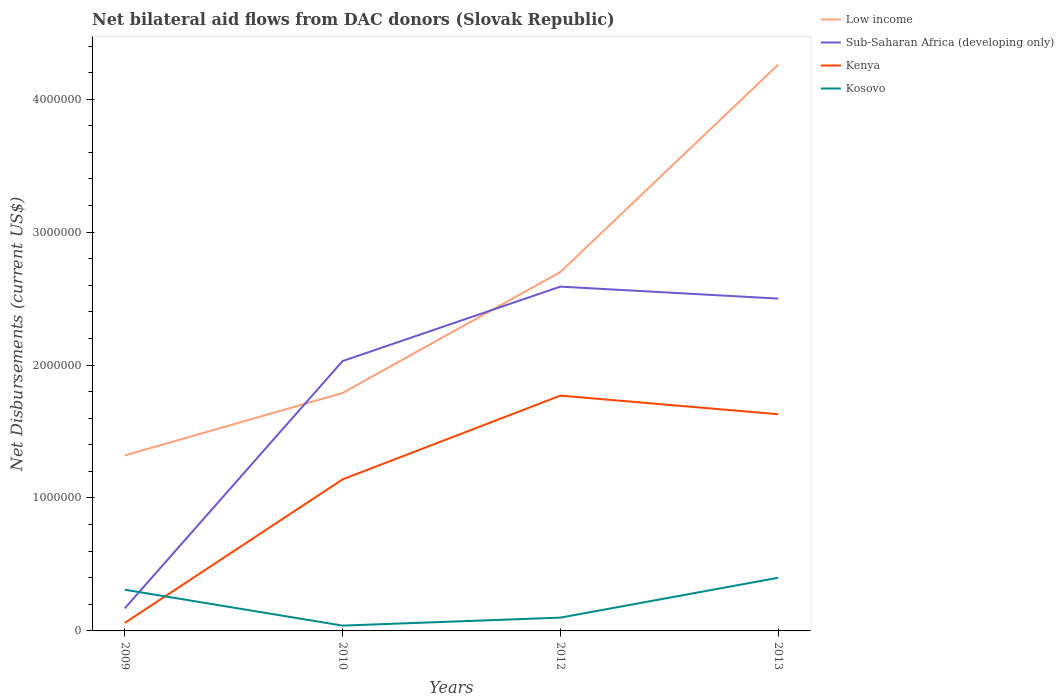Does the line corresponding to Sub-Saharan Africa (developing only) intersect with the line corresponding to Kosovo?
Your answer should be compact. Yes. What is the total net bilateral aid flows in Kosovo in the graph?
Your answer should be compact. -3.00e+05. What is the difference between the highest and the second highest net bilateral aid flows in Kenya?
Provide a succinct answer. 1.71e+06. What is the difference between the highest and the lowest net bilateral aid flows in Sub-Saharan Africa (developing only)?
Your response must be concise. 3. Is the net bilateral aid flows in Sub-Saharan Africa (developing only) strictly greater than the net bilateral aid flows in Low income over the years?
Keep it short and to the point. No. How many years are there in the graph?
Your answer should be compact. 4. Are the values on the major ticks of Y-axis written in scientific E-notation?
Ensure brevity in your answer.  No. Does the graph contain grids?
Your answer should be compact. No. How many legend labels are there?
Make the answer very short. 4. What is the title of the graph?
Your response must be concise. Net bilateral aid flows from DAC donors (Slovak Republic). Does "Angola" appear as one of the legend labels in the graph?
Your response must be concise. No. What is the label or title of the X-axis?
Give a very brief answer. Years. What is the label or title of the Y-axis?
Provide a succinct answer. Net Disbursements (current US$). What is the Net Disbursements (current US$) of Low income in 2009?
Keep it short and to the point. 1.32e+06. What is the Net Disbursements (current US$) in Sub-Saharan Africa (developing only) in 2009?
Offer a terse response. 1.70e+05. What is the Net Disbursements (current US$) of Kenya in 2009?
Offer a terse response. 6.00e+04. What is the Net Disbursements (current US$) of Kosovo in 2009?
Give a very brief answer. 3.10e+05. What is the Net Disbursements (current US$) in Low income in 2010?
Offer a terse response. 1.79e+06. What is the Net Disbursements (current US$) of Sub-Saharan Africa (developing only) in 2010?
Offer a terse response. 2.03e+06. What is the Net Disbursements (current US$) in Kenya in 2010?
Your answer should be very brief. 1.14e+06. What is the Net Disbursements (current US$) of Low income in 2012?
Offer a terse response. 2.70e+06. What is the Net Disbursements (current US$) of Sub-Saharan Africa (developing only) in 2012?
Give a very brief answer. 2.59e+06. What is the Net Disbursements (current US$) of Kenya in 2012?
Give a very brief answer. 1.77e+06. What is the Net Disbursements (current US$) of Low income in 2013?
Keep it short and to the point. 4.26e+06. What is the Net Disbursements (current US$) in Sub-Saharan Africa (developing only) in 2013?
Give a very brief answer. 2.50e+06. What is the Net Disbursements (current US$) in Kenya in 2013?
Give a very brief answer. 1.63e+06. Across all years, what is the maximum Net Disbursements (current US$) in Low income?
Provide a succinct answer. 4.26e+06. Across all years, what is the maximum Net Disbursements (current US$) in Sub-Saharan Africa (developing only)?
Your response must be concise. 2.59e+06. Across all years, what is the maximum Net Disbursements (current US$) in Kenya?
Ensure brevity in your answer.  1.77e+06. Across all years, what is the maximum Net Disbursements (current US$) of Kosovo?
Your answer should be compact. 4.00e+05. Across all years, what is the minimum Net Disbursements (current US$) of Low income?
Offer a terse response. 1.32e+06. Across all years, what is the minimum Net Disbursements (current US$) in Sub-Saharan Africa (developing only)?
Provide a succinct answer. 1.70e+05. Across all years, what is the minimum Net Disbursements (current US$) of Kenya?
Your answer should be very brief. 6.00e+04. Across all years, what is the minimum Net Disbursements (current US$) of Kosovo?
Give a very brief answer. 4.00e+04. What is the total Net Disbursements (current US$) of Low income in the graph?
Your answer should be very brief. 1.01e+07. What is the total Net Disbursements (current US$) in Sub-Saharan Africa (developing only) in the graph?
Ensure brevity in your answer.  7.29e+06. What is the total Net Disbursements (current US$) of Kenya in the graph?
Make the answer very short. 4.60e+06. What is the total Net Disbursements (current US$) in Kosovo in the graph?
Provide a succinct answer. 8.50e+05. What is the difference between the Net Disbursements (current US$) of Low income in 2009 and that in 2010?
Ensure brevity in your answer.  -4.70e+05. What is the difference between the Net Disbursements (current US$) in Sub-Saharan Africa (developing only) in 2009 and that in 2010?
Your response must be concise. -1.86e+06. What is the difference between the Net Disbursements (current US$) of Kenya in 2009 and that in 2010?
Ensure brevity in your answer.  -1.08e+06. What is the difference between the Net Disbursements (current US$) of Kosovo in 2009 and that in 2010?
Make the answer very short. 2.70e+05. What is the difference between the Net Disbursements (current US$) in Low income in 2009 and that in 2012?
Keep it short and to the point. -1.38e+06. What is the difference between the Net Disbursements (current US$) of Sub-Saharan Africa (developing only) in 2009 and that in 2012?
Make the answer very short. -2.42e+06. What is the difference between the Net Disbursements (current US$) in Kenya in 2009 and that in 2012?
Offer a terse response. -1.71e+06. What is the difference between the Net Disbursements (current US$) of Kosovo in 2009 and that in 2012?
Offer a terse response. 2.10e+05. What is the difference between the Net Disbursements (current US$) of Low income in 2009 and that in 2013?
Ensure brevity in your answer.  -2.94e+06. What is the difference between the Net Disbursements (current US$) of Sub-Saharan Africa (developing only) in 2009 and that in 2013?
Your answer should be very brief. -2.33e+06. What is the difference between the Net Disbursements (current US$) of Kenya in 2009 and that in 2013?
Offer a very short reply. -1.57e+06. What is the difference between the Net Disbursements (current US$) of Kosovo in 2009 and that in 2013?
Your answer should be very brief. -9.00e+04. What is the difference between the Net Disbursements (current US$) of Low income in 2010 and that in 2012?
Provide a succinct answer. -9.10e+05. What is the difference between the Net Disbursements (current US$) of Sub-Saharan Africa (developing only) in 2010 and that in 2012?
Offer a very short reply. -5.60e+05. What is the difference between the Net Disbursements (current US$) of Kenya in 2010 and that in 2012?
Your answer should be very brief. -6.30e+05. What is the difference between the Net Disbursements (current US$) of Low income in 2010 and that in 2013?
Make the answer very short. -2.47e+06. What is the difference between the Net Disbursements (current US$) of Sub-Saharan Africa (developing only) in 2010 and that in 2013?
Your answer should be compact. -4.70e+05. What is the difference between the Net Disbursements (current US$) of Kenya in 2010 and that in 2013?
Your answer should be compact. -4.90e+05. What is the difference between the Net Disbursements (current US$) in Kosovo in 2010 and that in 2013?
Offer a terse response. -3.60e+05. What is the difference between the Net Disbursements (current US$) of Low income in 2012 and that in 2013?
Your response must be concise. -1.56e+06. What is the difference between the Net Disbursements (current US$) in Kosovo in 2012 and that in 2013?
Ensure brevity in your answer.  -3.00e+05. What is the difference between the Net Disbursements (current US$) in Low income in 2009 and the Net Disbursements (current US$) in Sub-Saharan Africa (developing only) in 2010?
Make the answer very short. -7.10e+05. What is the difference between the Net Disbursements (current US$) of Low income in 2009 and the Net Disbursements (current US$) of Kenya in 2010?
Keep it short and to the point. 1.80e+05. What is the difference between the Net Disbursements (current US$) in Low income in 2009 and the Net Disbursements (current US$) in Kosovo in 2010?
Make the answer very short. 1.28e+06. What is the difference between the Net Disbursements (current US$) of Sub-Saharan Africa (developing only) in 2009 and the Net Disbursements (current US$) of Kenya in 2010?
Provide a succinct answer. -9.70e+05. What is the difference between the Net Disbursements (current US$) in Kenya in 2009 and the Net Disbursements (current US$) in Kosovo in 2010?
Your answer should be compact. 2.00e+04. What is the difference between the Net Disbursements (current US$) of Low income in 2009 and the Net Disbursements (current US$) of Sub-Saharan Africa (developing only) in 2012?
Offer a very short reply. -1.27e+06. What is the difference between the Net Disbursements (current US$) of Low income in 2009 and the Net Disbursements (current US$) of Kenya in 2012?
Ensure brevity in your answer.  -4.50e+05. What is the difference between the Net Disbursements (current US$) in Low income in 2009 and the Net Disbursements (current US$) in Kosovo in 2012?
Your answer should be very brief. 1.22e+06. What is the difference between the Net Disbursements (current US$) of Sub-Saharan Africa (developing only) in 2009 and the Net Disbursements (current US$) of Kenya in 2012?
Ensure brevity in your answer.  -1.60e+06. What is the difference between the Net Disbursements (current US$) of Sub-Saharan Africa (developing only) in 2009 and the Net Disbursements (current US$) of Kosovo in 2012?
Your response must be concise. 7.00e+04. What is the difference between the Net Disbursements (current US$) in Low income in 2009 and the Net Disbursements (current US$) in Sub-Saharan Africa (developing only) in 2013?
Offer a very short reply. -1.18e+06. What is the difference between the Net Disbursements (current US$) of Low income in 2009 and the Net Disbursements (current US$) of Kenya in 2013?
Ensure brevity in your answer.  -3.10e+05. What is the difference between the Net Disbursements (current US$) in Low income in 2009 and the Net Disbursements (current US$) in Kosovo in 2013?
Offer a very short reply. 9.20e+05. What is the difference between the Net Disbursements (current US$) of Sub-Saharan Africa (developing only) in 2009 and the Net Disbursements (current US$) of Kenya in 2013?
Offer a very short reply. -1.46e+06. What is the difference between the Net Disbursements (current US$) in Sub-Saharan Africa (developing only) in 2009 and the Net Disbursements (current US$) in Kosovo in 2013?
Provide a succinct answer. -2.30e+05. What is the difference between the Net Disbursements (current US$) of Low income in 2010 and the Net Disbursements (current US$) of Sub-Saharan Africa (developing only) in 2012?
Make the answer very short. -8.00e+05. What is the difference between the Net Disbursements (current US$) of Low income in 2010 and the Net Disbursements (current US$) of Kenya in 2012?
Your answer should be very brief. 2.00e+04. What is the difference between the Net Disbursements (current US$) in Low income in 2010 and the Net Disbursements (current US$) in Kosovo in 2012?
Offer a terse response. 1.69e+06. What is the difference between the Net Disbursements (current US$) of Sub-Saharan Africa (developing only) in 2010 and the Net Disbursements (current US$) of Kenya in 2012?
Ensure brevity in your answer.  2.60e+05. What is the difference between the Net Disbursements (current US$) in Sub-Saharan Africa (developing only) in 2010 and the Net Disbursements (current US$) in Kosovo in 2012?
Make the answer very short. 1.93e+06. What is the difference between the Net Disbursements (current US$) in Kenya in 2010 and the Net Disbursements (current US$) in Kosovo in 2012?
Provide a short and direct response. 1.04e+06. What is the difference between the Net Disbursements (current US$) in Low income in 2010 and the Net Disbursements (current US$) in Sub-Saharan Africa (developing only) in 2013?
Your answer should be very brief. -7.10e+05. What is the difference between the Net Disbursements (current US$) in Low income in 2010 and the Net Disbursements (current US$) in Kosovo in 2013?
Provide a succinct answer. 1.39e+06. What is the difference between the Net Disbursements (current US$) of Sub-Saharan Africa (developing only) in 2010 and the Net Disbursements (current US$) of Kosovo in 2013?
Your answer should be compact. 1.63e+06. What is the difference between the Net Disbursements (current US$) of Kenya in 2010 and the Net Disbursements (current US$) of Kosovo in 2013?
Offer a very short reply. 7.40e+05. What is the difference between the Net Disbursements (current US$) of Low income in 2012 and the Net Disbursements (current US$) of Kenya in 2013?
Your response must be concise. 1.07e+06. What is the difference between the Net Disbursements (current US$) in Low income in 2012 and the Net Disbursements (current US$) in Kosovo in 2013?
Offer a very short reply. 2.30e+06. What is the difference between the Net Disbursements (current US$) in Sub-Saharan Africa (developing only) in 2012 and the Net Disbursements (current US$) in Kenya in 2013?
Make the answer very short. 9.60e+05. What is the difference between the Net Disbursements (current US$) in Sub-Saharan Africa (developing only) in 2012 and the Net Disbursements (current US$) in Kosovo in 2013?
Your answer should be very brief. 2.19e+06. What is the difference between the Net Disbursements (current US$) in Kenya in 2012 and the Net Disbursements (current US$) in Kosovo in 2013?
Your response must be concise. 1.37e+06. What is the average Net Disbursements (current US$) of Low income per year?
Your response must be concise. 2.52e+06. What is the average Net Disbursements (current US$) of Sub-Saharan Africa (developing only) per year?
Your answer should be compact. 1.82e+06. What is the average Net Disbursements (current US$) of Kenya per year?
Offer a terse response. 1.15e+06. What is the average Net Disbursements (current US$) of Kosovo per year?
Offer a terse response. 2.12e+05. In the year 2009, what is the difference between the Net Disbursements (current US$) in Low income and Net Disbursements (current US$) in Sub-Saharan Africa (developing only)?
Make the answer very short. 1.15e+06. In the year 2009, what is the difference between the Net Disbursements (current US$) in Low income and Net Disbursements (current US$) in Kenya?
Keep it short and to the point. 1.26e+06. In the year 2009, what is the difference between the Net Disbursements (current US$) in Low income and Net Disbursements (current US$) in Kosovo?
Make the answer very short. 1.01e+06. In the year 2009, what is the difference between the Net Disbursements (current US$) in Kenya and Net Disbursements (current US$) in Kosovo?
Your response must be concise. -2.50e+05. In the year 2010, what is the difference between the Net Disbursements (current US$) in Low income and Net Disbursements (current US$) in Sub-Saharan Africa (developing only)?
Give a very brief answer. -2.40e+05. In the year 2010, what is the difference between the Net Disbursements (current US$) in Low income and Net Disbursements (current US$) in Kenya?
Offer a terse response. 6.50e+05. In the year 2010, what is the difference between the Net Disbursements (current US$) in Low income and Net Disbursements (current US$) in Kosovo?
Offer a terse response. 1.75e+06. In the year 2010, what is the difference between the Net Disbursements (current US$) of Sub-Saharan Africa (developing only) and Net Disbursements (current US$) of Kenya?
Provide a succinct answer. 8.90e+05. In the year 2010, what is the difference between the Net Disbursements (current US$) of Sub-Saharan Africa (developing only) and Net Disbursements (current US$) of Kosovo?
Provide a succinct answer. 1.99e+06. In the year 2010, what is the difference between the Net Disbursements (current US$) of Kenya and Net Disbursements (current US$) of Kosovo?
Give a very brief answer. 1.10e+06. In the year 2012, what is the difference between the Net Disbursements (current US$) of Low income and Net Disbursements (current US$) of Sub-Saharan Africa (developing only)?
Offer a very short reply. 1.10e+05. In the year 2012, what is the difference between the Net Disbursements (current US$) of Low income and Net Disbursements (current US$) of Kenya?
Keep it short and to the point. 9.30e+05. In the year 2012, what is the difference between the Net Disbursements (current US$) in Low income and Net Disbursements (current US$) in Kosovo?
Offer a very short reply. 2.60e+06. In the year 2012, what is the difference between the Net Disbursements (current US$) in Sub-Saharan Africa (developing only) and Net Disbursements (current US$) in Kenya?
Your answer should be compact. 8.20e+05. In the year 2012, what is the difference between the Net Disbursements (current US$) in Sub-Saharan Africa (developing only) and Net Disbursements (current US$) in Kosovo?
Provide a short and direct response. 2.49e+06. In the year 2012, what is the difference between the Net Disbursements (current US$) of Kenya and Net Disbursements (current US$) of Kosovo?
Offer a very short reply. 1.67e+06. In the year 2013, what is the difference between the Net Disbursements (current US$) in Low income and Net Disbursements (current US$) in Sub-Saharan Africa (developing only)?
Your answer should be very brief. 1.76e+06. In the year 2013, what is the difference between the Net Disbursements (current US$) of Low income and Net Disbursements (current US$) of Kenya?
Your answer should be very brief. 2.63e+06. In the year 2013, what is the difference between the Net Disbursements (current US$) in Low income and Net Disbursements (current US$) in Kosovo?
Your answer should be very brief. 3.86e+06. In the year 2013, what is the difference between the Net Disbursements (current US$) in Sub-Saharan Africa (developing only) and Net Disbursements (current US$) in Kenya?
Give a very brief answer. 8.70e+05. In the year 2013, what is the difference between the Net Disbursements (current US$) in Sub-Saharan Africa (developing only) and Net Disbursements (current US$) in Kosovo?
Provide a short and direct response. 2.10e+06. In the year 2013, what is the difference between the Net Disbursements (current US$) in Kenya and Net Disbursements (current US$) in Kosovo?
Offer a terse response. 1.23e+06. What is the ratio of the Net Disbursements (current US$) of Low income in 2009 to that in 2010?
Ensure brevity in your answer.  0.74. What is the ratio of the Net Disbursements (current US$) in Sub-Saharan Africa (developing only) in 2009 to that in 2010?
Your response must be concise. 0.08. What is the ratio of the Net Disbursements (current US$) in Kenya in 2009 to that in 2010?
Offer a terse response. 0.05. What is the ratio of the Net Disbursements (current US$) of Kosovo in 2009 to that in 2010?
Your answer should be very brief. 7.75. What is the ratio of the Net Disbursements (current US$) in Low income in 2009 to that in 2012?
Ensure brevity in your answer.  0.49. What is the ratio of the Net Disbursements (current US$) in Sub-Saharan Africa (developing only) in 2009 to that in 2012?
Make the answer very short. 0.07. What is the ratio of the Net Disbursements (current US$) of Kenya in 2009 to that in 2012?
Your answer should be very brief. 0.03. What is the ratio of the Net Disbursements (current US$) of Low income in 2009 to that in 2013?
Ensure brevity in your answer.  0.31. What is the ratio of the Net Disbursements (current US$) in Sub-Saharan Africa (developing only) in 2009 to that in 2013?
Offer a terse response. 0.07. What is the ratio of the Net Disbursements (current US$) of Kenya in 2009 to that in 2013?
Your response must be concise. 0.04. What is the ratio of the Net Disbursements (current US$) of Kosovo in 2009 to that in 2013?
Give a very brief answer. 0.78. What is the ratio of the Net Disbursements (current US$) in Low income in 2010 to that in 2012?
Make the answer very short. 0.66. What is the ratio of the Net Disbursements (current US$) in Sub-Saharan Africa (developing only) in 2010 to that in 2012?
Your response must be concise. 0.78. What is the ratio of the Net Disbursements (current US$) in Kenya in 2010 to that in 2012?
Provide a short and direct response. 0.64. What is the ratio of the Net Disbursements (current US$) in Low income in 2010 to that in 2013?
Your answer should be compact. 0.42. What is the ratio of the Net Disbursements (current US$) in Sub-Saharan Africa (developing only) in 2010 to that in 2013?
Make the answer very short. 0.81. What is the ratio of the Net Disbursements (current US$) in Kenya in 2010 to that in 2013?
Keep it short and to the point. 0.7. What is the ratio of the Net Disbursements (current US$) in Low income in 2012 to that in 2013?
Provide a short and direct response. 0.63. What is the ratio of the Net Disbursements (current US$) in Sub-Saharan Africa (developing only) in 2012 to that in 2013?
Make the answer very short. 1.04. What is the ratio of the Net Disbursements (current US$) in Kenya in 2012 to that in 2013?
Provide a succinct answer. 1.09. What is the ratio of the Net Disbursements (current US$) of Kosovo in 2012 to that in 2013?
Your answer should be very brief. 0.25. What is the difference between the highest and the second highest Net Disbursements (current US$) of Low income?
Offer a terse response. 1.56e+06. What is the difference between the highest and the second highest Net Disbursements (current US$) in Sub-Saharan Africa (developing only)?
Your answer should be compact. 9.00e+04. What is the difference between the highest and the second highest Net Disbursements (current US$) of Kosovo?
Keep it short and to the point. 9.00e+04. What is the difference between the highest and the lowest Net Disbursements (current US$) of Low income?
Your response must be concise. 2.94e+06. What is the difference between the highest and the lowest Net Disbursements (current US$) of Sub-Saharan Africa (developing only)?
Make the answer very short. 2.42e+06. What is the difference between the highest and the lowest Net Disbursements (current US$) in Kenya?
Your response must be concise. 1.71e+06. What is the difference between the highest and the lowest Net Disbursements (current US$) of Kosovo?
Provide a succinct answer. 3.60e+05. 